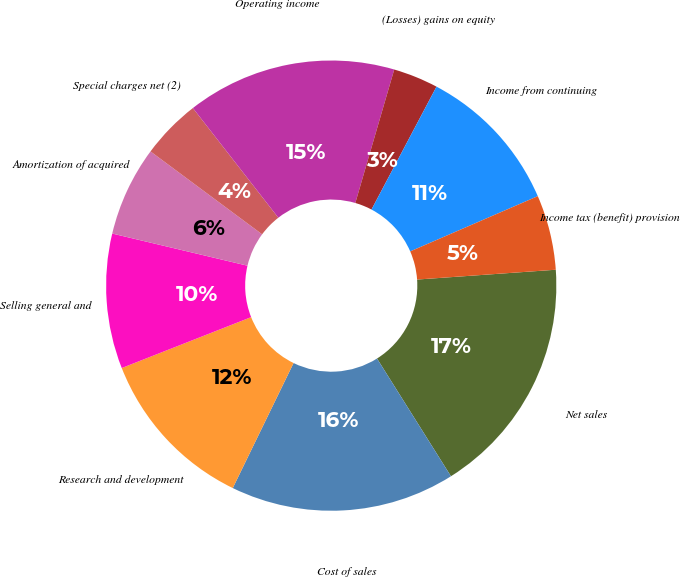<chart> <loc_0><loc_0><loc_500><loc_500><pie_chart><fcel>Net sales<fcel>Cost of sales<fcel>Research and development<fcel>Selling general and<fcel>Amortization of acquired<fcel>Special charges net (2)<fcel>Operating income<fcel>(Losses) gains on equity<fcel>Income from continuing<fcel>Income tax (benefit) provision<nl><fcel>17.2%<fcel>16.13%<fcel>11.83%<fcel>9.68%<fcel>6.45%<fcel>4.3%<fcel>15.05%<fcel>3.23%<fcel>10.75%<fcel>5.38%<nl></chart> 